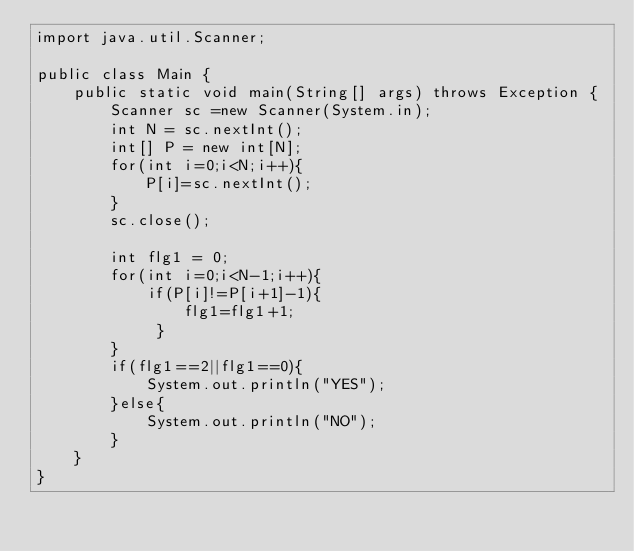<code> <loc_0><loc_0><loc_500><loc_500><_Java_>import java.util.Scanner;

public class Main {
    public static void main(String[] args) throws Exception {
        Scanner sc =new Scanner(System.in);
        int N = sc.nextInt();
        int[] P = new int[N];
        for(int i=0;i<N;i++){
            P[i]=sc.nextInt();
        }
        sc.close();

        int flg1 = 0;
        for(int i=0;i<N-1;i++){
            if(P[i]!=P[i+1]-1){
                flg1=flg1+1;
             }
        }
        if(flg1==2||flg1==0){
            System.out.println("YES");
        }else{
            System.out.println("NO");
        }
    }
}</code> 